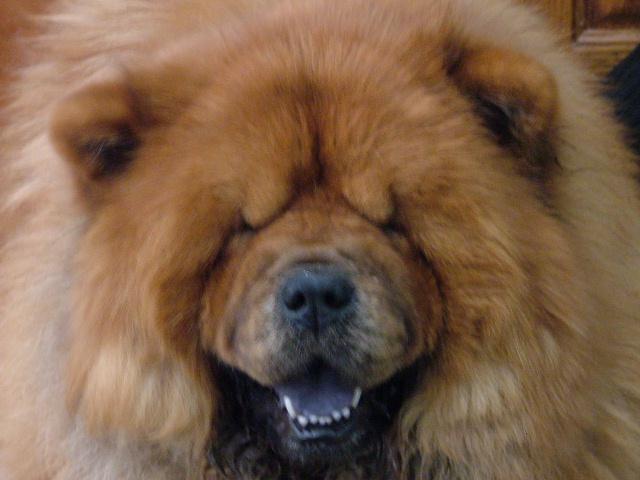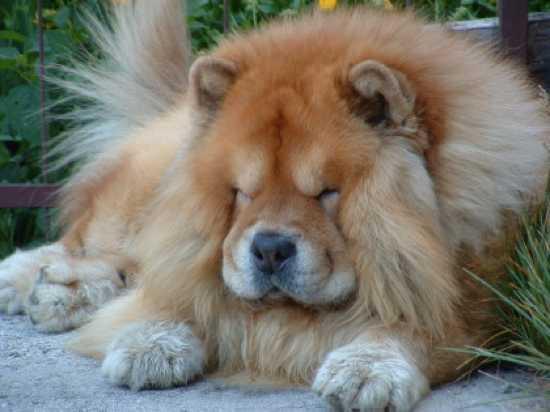The first image is the image on the left, the second image is the image on the right. Analyze the images presented: Is the assertion "One of the images only shows the head of a dog." valid? Answer yes or no. Yes. 